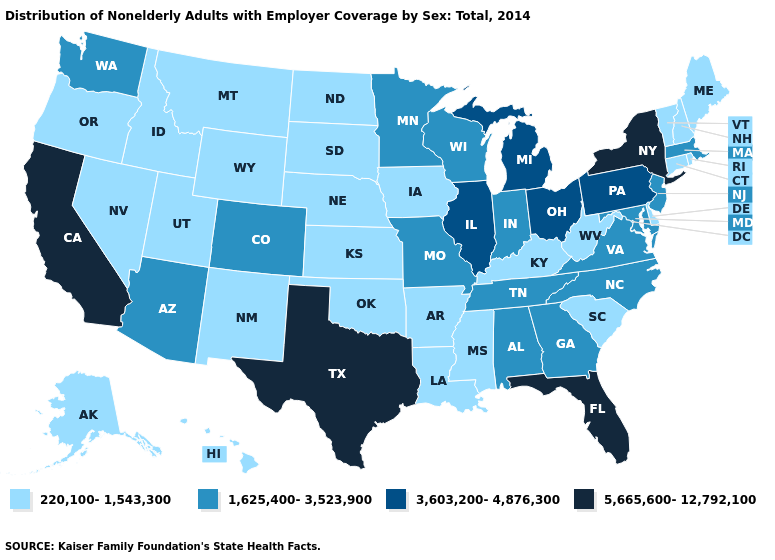What is the highest value in the MidWest ?
Short answer required. 3,603,200-4,876,300. Is the legend a continuous bar?
Short answer required. No. What is the lowest value in the West?
Quick response, please. 220,100-1,543,300. Name the states that have a value in the range 3,603,200-4,876,300?
Keep it brief. Illinois, Michigan, Ohio, Pennsylvania. What is the value of Washington?
Give a very brief answer. 1,625,400-3,523,900. Does West Virginia have the lowest value in the USA?
Be succinct. Yes. Among the states that border Arizona , does New Mexico have the lowest value?
Write a very short answer. Yes. Which states have the lowest value in the South?
Answer briefly. Arkansas, Delaware, Kentucky, Louisiana, Mississippi, Oklahoma, South Carolina, West Virginia. Name the states that have a value in the range 220,100-1,543,300?
Be succinct. Alaska, Arkansas, Connecticut, Delaware, Hawaii, Idaho, Iowa, Kansas, Kentucky, Louisiana, Maine, Mississippi, Montana, Nebraska, Nevada, New Hampshire, New Mexico, North Dakota, Oklahoma, Oregon, Rhode Island, South Carolina, South Dakota, Utah, Vermont, West Virginia, Wyoming. Does the first symbol in the legend represent the smallest category?
Concise answer only. Yes. Does Illinois have the lowest value in the USA?
Give a very brief answer. No. Which states have the lowest value in the USA?
Quick response, please. Alaska, Arkansas, Connecticut, Delaware, Hawaii, Idaho, Iowa, Kansas, Kentucky, Louisiana, Maine, Mississippi, Montana, Nebraska, Nevada, New Hampshire, New Mexico, North Dakota, Oklahoma, Oregon, Rhode Island, South Carolina, South Dakota, Utah, Vermont, West Virginia, Wyoming. What is the value of Nebraska?
Answer briefly. 220,100-1,543,300. What is the value of California?
Quick response, please. 5,665,600-12,792,100. 